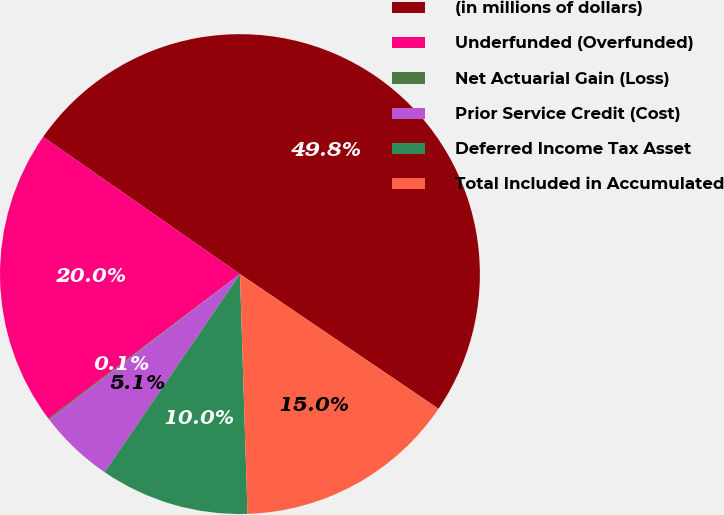Convert chart to OTSL. <chart><loc_0><loc_0><loc_500><loc_500><pie_chart><fcel>(in millions of dollars)<fcel>Underfunded (Overfunded)<fcel>Net Actuarial Gain (Loss)<fcel>Prior Service Credit (Cost)<fcel>Deferred Income Tax Asset<fcel>Total Included in Accumulated<nl><fcel>49.8%<fcel>19.98%<fcel>0.1%<fcel>5.07%<fcel>10.04%<fcel>15.01%<nl></chart> 